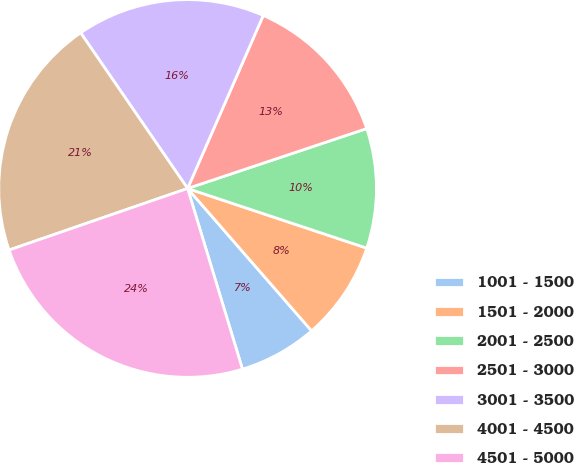Convert chart to OTSL. <chart><loc_0><loc_0><loc_500><loc_500><pie_chart><fcel>1001 - 1500<fcel>1501 - 2000<fcel>2001 - 2500<fcel>2501 - 3000<fcel>3001 - 3500<fcel>4001 - 4500<fcel>4501 - 5000<nl><fcel>6.71%<fcel>8.48%<fcel>10.25%<fcel>13.3%<fcel>16.14%<fcel>20.7%<fcel>24.4%<nl></chart> 